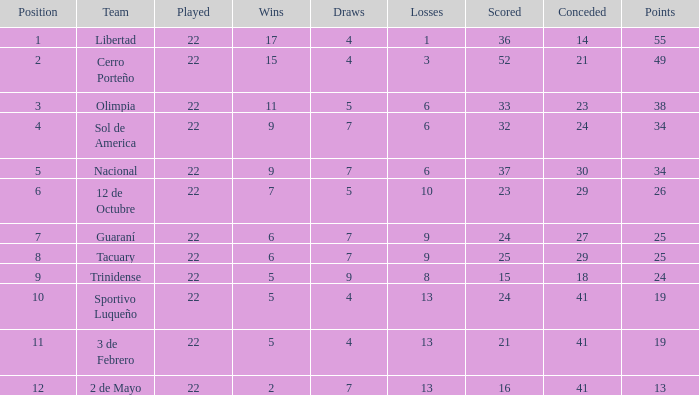What is the total of draws for the side with more than 8 setbacks and 13 points? 7.0. 